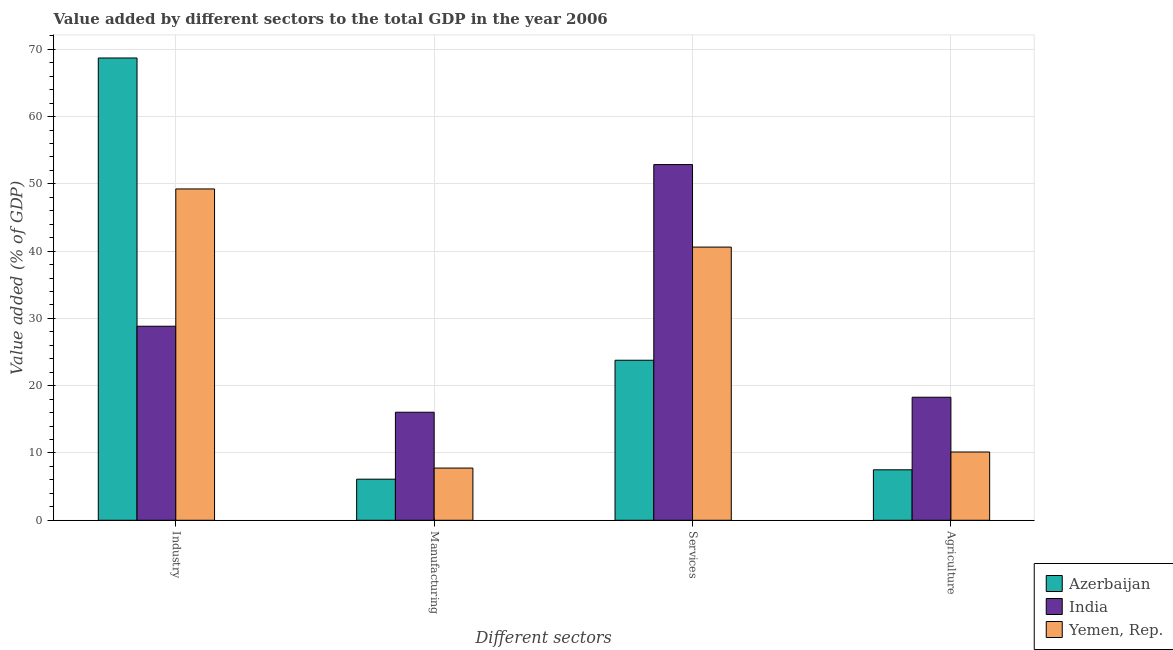Are the number of bars per tick equal to the number of legend labels?
Offer a very short reply. Yes. How many bars are there on the 2nd tick from the left?
Provide a short and direct response. 3. How many bars are there on the 4th tick from the right?
Provide a succinct answer. 3. What is the label of the 1st group of bars from the left?
Provide a short and direct response. Industry. What is the value added by industrial sector in Yemen, Rep.?
Provide a short and direct response. 49.25. Across all countries, what is the maximum value added by manufacturing sector?
Your answer should be very brief. 16.06. Across all countries, what is the minimum value added by agricultural sector?
Provide a succinct answer. 7.5. In which country was the value added by agricultural sector maximum?
Your response must be concise. India. In which country was the value added by manufacturing sector minimum?
Keep it short and to the point. Azerbaijan. What is the total value added by services sector in the graph?
Keep it short and to the point. 117.26. What is the difference between the value added by services sector in Yemen, Rep. and that in India?
Provide a succinct answer. -12.26. What is the difference between the value added by services sector in Azerbaijan and the value added by agricultural sector in Yemen, Rep.?
Offer a very short reply. 13.64. What is the average value added by services sector per country?
Give a very brief answer. 39.09. What is the difference between the value added by industrial sector and value added by agricultural sector in India?
Give a very brief answer. 10.55. In how many countries, is the value added by industrial sector greater than 56 %?
Ensure brevity in your answer.  1. What is the ratio of the value added by agricultural sector in Yemen, Rep. to that in India?
Your response must be concise. 0.55. Is the value added by agricultural sector in Yemen, Rep. less than that in Azerbaijan?
Your response must be concise. No. Is the difference between the value added by industrial sector in Yemen, Rep. and India greater than the difference between the value added by agricultural sector in Yemen, Rep. and India?
Give a very brief answer. Yes. What is the difference between the highest and the second highest value added by agricultural sector?
Your response must be concise. 8.14. What is the difference between the highest and the lowest value added by services sector?
Offer a very short reply. 29.08. In how many countries, is the value added by manufacturing sector greater than the average value added by manufacturing sector taken over all countries?
Provide a succinct answer. 1. Is it the case that in every country, the sum of the value added by services sector and value added by agricultural sector is greater than the sum of value added by industrial sector and value added by manufacturing sector?
Your answer should be compact. Yes. What does the 3rd bar from the left in Manufacturing represents?
Offer a terse response. Yemen, Rep. What does the 3rd bar from the right in Manufacturing represents?
Provide a short and direct response. Azerbaijan. How many bars are there?
Your answer should be compact. 12. Are all the bars in the graph horizontal?
Offer a terse response. No. Are the values on the major ticks of Y-axis written in scientific E-notation?
Provide a succinct answer. No. Does the graph contain grids?
Your answer should be very brief. Yes. What is the title of the graph?
Give a very brief answer. Value added by different sectors to the total GDP in the year 2006. Does "Somalia" appear as one of the legend labels in the graph?
Provide a succinct answer. No. What is the label or title of the X-axis?
Ensure brevity in your answer.  Different sectors. What is the label or title of the Y-axis?
Provide a short and direct response. Value added (% of GDP). What is the Value added (% of GDP) in Azerbaijan in Industry?
Keep it short and to the point. 68.71. What is the Value added (% of GDP) in India in Industry?
Your response must be concise. 28.84. What is the Value added (% of GDP) of Yemen, Rep. in Industry?
Your response must be concise. 49.25. What is the Value added (% of GDP) of Azerbaijan in Manufacturing?
Offer a terse response. 6.11. What is the Value added (% of GDP) of India in Manufacturing?
Your answer should be very brief. 16.06. What is the Value added (% of GDP) of Yemen, Rep. in Manufacturing?
Ensure brevity in your answer.  7.76. What is the Value added (% of GDP) in Azerbaijan in Services?
Make the answer very short. 23.79. What is the Value added (% of GDP) of India in Services?
Make the answer very short. 52.87. What is the Value added (% of GDP) in Yemen, Rep. in Services?
Offer a very short reply. 40.61. What is the Value added (% of GDP) of Azerbaijan in Agriculture?
Ensure brevity in your answer.  7.5. What is the Value added (% of GDP) of India in Agriculture?
Make the answer very short. 18.29. What is the Value added (% of GDP) in Yemen, Rep. in Agriculture?
Ensure brevity in your answer.  10.15. Across all Different sectors, what is the maximum Value added (% of GDP) in Azerbaijan?
Your answer should be very brief. 68.71. Across all Different sectors, what is the maximum Value added (% of GDP) of India?
Your answer should be very brief. 52.87. Across all Different sectors, what is the maximum Value added (% of GDP) in Yemen, Rep.?
Keep it short and to the point. 49.25. Across all Different sectors, what is the minimum Value added (% of GDP) in Azerbaijan?
Ensure brevity in your answer.  6.11. Across all Different sectors, what is the minimum Value added (% of GDP) of India?
Your response must be concise. 16.06. Across all Different sectors, what is the minimum Value added (% of GDP) of Yemen, Rep.?
Your response must be concise. 7.76. What is the total Value added (% of GDP) of Azerbaijan in the graph?
Offer a terse response. 106.11. What is the total Value added (% of GDP) of India in the graph?
Ensure brevity in your answer.  116.06. What is the total Value added (% of GDP) in Yemen, Rep. in the graph?
Make the answer very short. 107.76. What is the difference between the Value added (% of GDP) in Azerbaijan in Industry and that in Manufacturing?
Ensure brevity in your answer.  62.61. What is the difference between the Value added (% of GDP) in India in Industry and that in Manufacturing?
Offer a terse response. 12.78. What is the difference between the Value added (% of GDP) of Yemen, Rep. in Industry and that in Manufacturing?
Your response must be concise. 41.49. What is the difference between the Value added (% of GDP) of Azerbaijan in Industry and that in Services?
Your answer should be compact. 44.93. What is the difference between the Value added (% of GDP) in India in Industry and that in Services?
Your answer should be compact. -24.03. What is the difference between the Value added (% of GDP) in Yemen, Rep. in Industry and that in Services?
Make the answer very short. 8.64. What is the difference between the Value added (% of GDP) of Azerbaijan in Industry and that in Agriculture?
Your answer should be compact. 61.21. What is the difference between the Value added (% of GDP) in India in Industry and that in Agriculture?
Provide a short and direct response. 10.55. What is the difference between the Value added (% of GDP) in Yemen, Rep. in Industry and that in Agriculture?
Ensure brevity in your answer.  39.1. What is the difference between the Value added (% of GDP) in Azerbaijan in Manufacturing and that in Services?
Provide a succinct answer. -17.68. What is the difference between the Value added (% of GDP) of India in Manufacturing and that in Services?
Keep it short and to the point. -36.81. What is the difference between the Value added (% of GDP) in Yemen, Rep. in Manufacturing and that in Services?
Your response must be concise. -32.85. What is the difference between the Value added (% of GDP) of Azerbaijan in Manufacturing and that in Agriculture?
Provide a succinct answer. -1.39. What is the difference between the Value added (% of GDP) of India in Manufacturing and that in Agriculture?
Your answer should be very brief. -2.23. What is the difference between the Value added (% of GDP) in Yemen, Rep. in Manufacturing and that in Agriculture?
Provide a succinct answer. -2.39. What is the difference between the Value added (% of GDP) in Azerbaijan in Services and that in Agriculture?
Keep it short and to the point. 16.29. What is the difference between the Value added (% of GDP) of India in Services and that in Agriculture?
Provide a short and direct response. 34.58. What is the difference between the Value added (% of GDP) in Yemen, Rep. in Services and that in Agriculture?
Offer a very short reply. 30.46. What is the difference between the Value added (% of GDP) in Azerbaijan in Industry and the Value added (% of GDP) in India in Manufacturing?
Your answer should be compact. 52.65. What is the difference between the Value added (% of GDP) of Azerbaijan in Industry and the Value added (% of GDP) of Yemen, Rep. in Manufacturing?
Ensure brevity in your answer.  60.95. What is the difference between the Value added (% of GDP) of India in Industry and the Value added (% of GDP) of Yemen, Rep. in Manufacturing?
Ensure brevity in your answer.  21.08. What is the difference between the Value added (% of GDP) in Azerbaijan in Industry and the Value added (% of GDP) in India in Services?
Make the answer very short. 15.84. What is the difference between the Value added (% of GDP) of Azerbaijan in Industry and the Value added (% of GDP) of Yemen, Rep. in Services?
Keep it short and to the point. 28.11. What is the difference between the Value added (% of GDP) of India in Industry and the Value added (% of GDP) of Yemen, Rep. in Services?
Give a very brief answer. -11.76. What is the difference between the Value added (% of GDP) of Azerbaijan in Industry and the Value added (% of GDP) of India in Agriculture?
Provide a short and direct response. 50.42. What is the difference between the Value added (% of GDP) of Azerbaijan in Industry and the Value added (% of GDP) of Yemen, Rep. in Agriculture?
Offer a terse response. 58.57. What is the difference between the Value added (% of GDP) in India in Industry and the Value added (% of GDP) in Yemen, Rep. in Agriculture?
Provide a short and direct response. 18.69. What is the difference between the Value added (% of GDP) in Azerbaijan in Manufacturing and the Value added (% of GDP) in India in Services?
Offer a terse response. -46.76. What is the difference between the Value added (% of GDP) of Azerbaijan in Manufacturing and the Value added (% of GDP) of Yemen, Rep. in Services?
Make the answer very short. -34.5. What is the difference between the Value added (% of GDP) in India in Manufacturing and the Value added (% of GDP) in Yemen, Rep. in Services?
Give a very brief answer. -24.55. What is the difference between the Value added (% of GDP) of Azerbaijan in Manufacturing and the Value added (% of GDP) of India in Agriculture?
Keep it short and to the point. -12.18. What is the difference between the Value added (% of GDP) of Azerbaijan in Manufacturing and the Value added (% of GDP) of Yemen, Rep. in Agriculture?
Offer a terse response. -4.04. What is the difference between the Value added (% of GDP) in India in Manufacturing and the Value added (% of GDP) in Yemen, Rep. in Agriculture?
Your answer should be very brief. 5.91. What is the difference between the Value added (% of GDP) in Azerbaijan in Services and the Value added (% of GDP) in India in Agriculture?
Provide a succinct answer. 5.5. What is the difference between the Value added (% of GDP) of Azerbaijan in Services and the Value added (% of GDP) of Yemen, Rep. in Agriculture?
Offer a terse response. 13.64. What is the difference between the Value added (% of GDP) in India in Services and the Value added (% of GDP) in Yemen, Rep. in Agriculture?
Give a very brief answer. 42.72. What is the average Value added (% of GDP) of Azerbaijan per Different sectors?
Your response must be concise. 26.53. What is the average Value added (% of GDP) of India per Different sectors?
Offer a very short reply. 29.01. What is the average Value added (% of GDP) of Yemen, Rep. per Different sectors?
Keep it short and to the point. 26.94. What is the difference between the Value added (% of GDP) in Azerbaijan and Value added (% of GDP) in India in Industry?
Keep it short and to the point. 39.87. What is the difference between the Value added (% of GDP) of Azerbaijan and Value added (% of GDP) of Yemen, Rep. in Industry?
Your response must be concise. 19.47. What is the difference between the Value added (% of GDP) of India and Value added (% of GDP) of Yemen, Rep. in Industry?
Offer a very short reply. -20.41. What is the difference between the Value added (% of GDP) in Azerbaijan and Value added (% of GDP) in India in Manufacturing?
Provide a short and direct response. -9.95. What is the difference between the Value added (% of GDP) of Azerbaijan and Value added (% of GDP) of Yemen, Rep. in Manufacturing?
Offer a terse response. -1.65. What is the difference between the Value added (% of GDP) in India and Value added (% of GDP) in Yemen, Rep. in Manufacturing?
Provide a short and direct response. 8.3. What is the difference between the Value added (% of GDP) in Azerbaijan and Value added (% of GDP) in India in Services?
Keep it short and to the point. -29.08. What is the difference between the Value added (% of GDP) in Azerbaijan and Value added (% of GDP) in Yemen, Rep. in Services?
Provide a short and direct response. -16.82. What is the difference between the Value added (% of GDP) in India and Value added (% of GDP) in Yemen, Rep. in Services?
Provide a short and direct response. 12.26. What is the difference between the Value added (% of GDP) of Azerbaijan and Value added (% of GDP) of India in Agriculture?
Offer a very short reply. -10.79. What is the difference between the Value added (% of GDP) in Azerbaijan and Value added (% of GDP) in Yemen, Rep. in Agriculture?
Your answer should be compact. -2.65. What is the difference between the Value added (% of GDP) in India and Value added (% of GDP) in Yemen, Rep. in Agriculture?
Offer a very short reply. 8.14. What is the ratio of the Value added (% of GDP) of Azerbaijan in Industry to that in Manufacturing?
Ensure brevity in your answer.  11.25. What is the ratio of the Value added (% of GDP) of India in Industry to that in Manufacturing?
Provide a succinct answer. 1.8. What is the ratio of the Value added (% of GDP) of Yemen, Rep. in Industry to that in Manufacturing?
Give a very brief answer. 6.35. What is the ratio of the Value added (% of GDP) in Azerbaijan in Industry to that in Services?
Offer a very short reply. 2.89. What is the ratio of the Value added (% of GDP) of India in Industry to that in Services?
Your answer should be compact. 0.55. What is the ratio of the Value added (% of GDP) of Yemen, Rep. in Industry to that in Services?
Give a very brief answer. 1.21. What is the ratio of the Value added (% of GDP) in Azerbaijan in Industry to that in Agriculture?
Your answer should be compact. 9.16. What is the ratio of the Value added (% of GDP) in India in Industry to that in Agriculture?
Your response must be concise. 1.58. What is the ratio of the Value added (% of GDP) of Yemen, Rep. in Industry to that in Agriculture?
Provide a short and direct response. 4.85. What is the ratio of the Value added (% of GDP) of Azerbaijan in Manufacturing to that in Services?
Give a very brief answer. 0.26. What is the ratio of the Value added (% of GDP) in India in Manufacturing to that in Services?
Give a very brief answer. 0.3. What is the ratio of the Value added (% of GDP) in Yemen, Rep. in Manufacturing to that in Services?
Make the answer very short. 0.19. What is the ratio of the Value added (% of GDP) in Azerbaijan in Manufacturing to that in Agriculture?
Keep it short and to the point. 0.81. What is the ratio of the Value added (% of GDP) in India in Manufacturing to that in Agriculture?
Provide a short and direct response. 0.88. What is the ratio of the Value added (% of GDP) of Yemen, Rep. in Manufacturing to that in Agriculture?
Offer a very short reply. 0.76. What is the ratio of the Value added (% of GDP) in Azerbaijan in Services to that in Agriculture?
Your response must be concise. 3.17. What is the ratio of the Value added (% of GDP) in India in Services to that in Agriculture?
Provide a succinct answer. 2.89. What is the ratio of the Value added (% of GDP) of Yemen, Rep. in Services to that in Agriculture?
Offer a terse response. 4. What is the difference between the highest and the second highest Value added (% of GDP) in Azerbaijan?
Offer a very short reply. 44.93. What is the difference between the highest and the second highest Value added (% of GDP) of India?
Your answer should be very brief. 24.03. What is the difference between the highest and the second highest Value added (% of GDP) of Yemen, Rep.?
Offer a terse response. 8.64. What is the difference between the highest and the lowest Value added (% of GDP) of Azerbaijan?
Offer a very short reply. 62.61. What is the difference between the highest and the lowest Value added (% of GDP) in India?
Give a very brief answer. 36.81. What is the difference between the highest and the lowest Value added (% of GDP) of Yemen, Rep.?
Your answer should be compact. 41.49. 